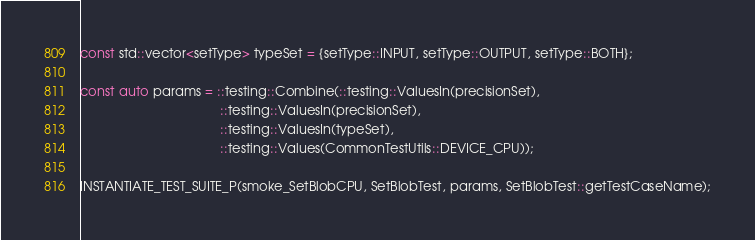<code> <loc_0><loc_0><loc_500><loc_500><_C++_>const std::vector<setType> typeSet = {setType::INPUT, setType::OUTPUT, setType::BOTH};

const auto params = ::testing::Combine(::testing::ValuesIn(precisionSet),
                                       ::testing::ValuesIn(precisionSet),
                                       ::testing::ValuesIn(typeSet),
                                       ::testing::Values(CommonTestUtils::DEVICE_CPU));

INSTANTIATE_TEST_SUITE_P(smoke_SetBlobCPU, SetBlobTest, params, SetBlobTest::getTestCaseName);
</code> 